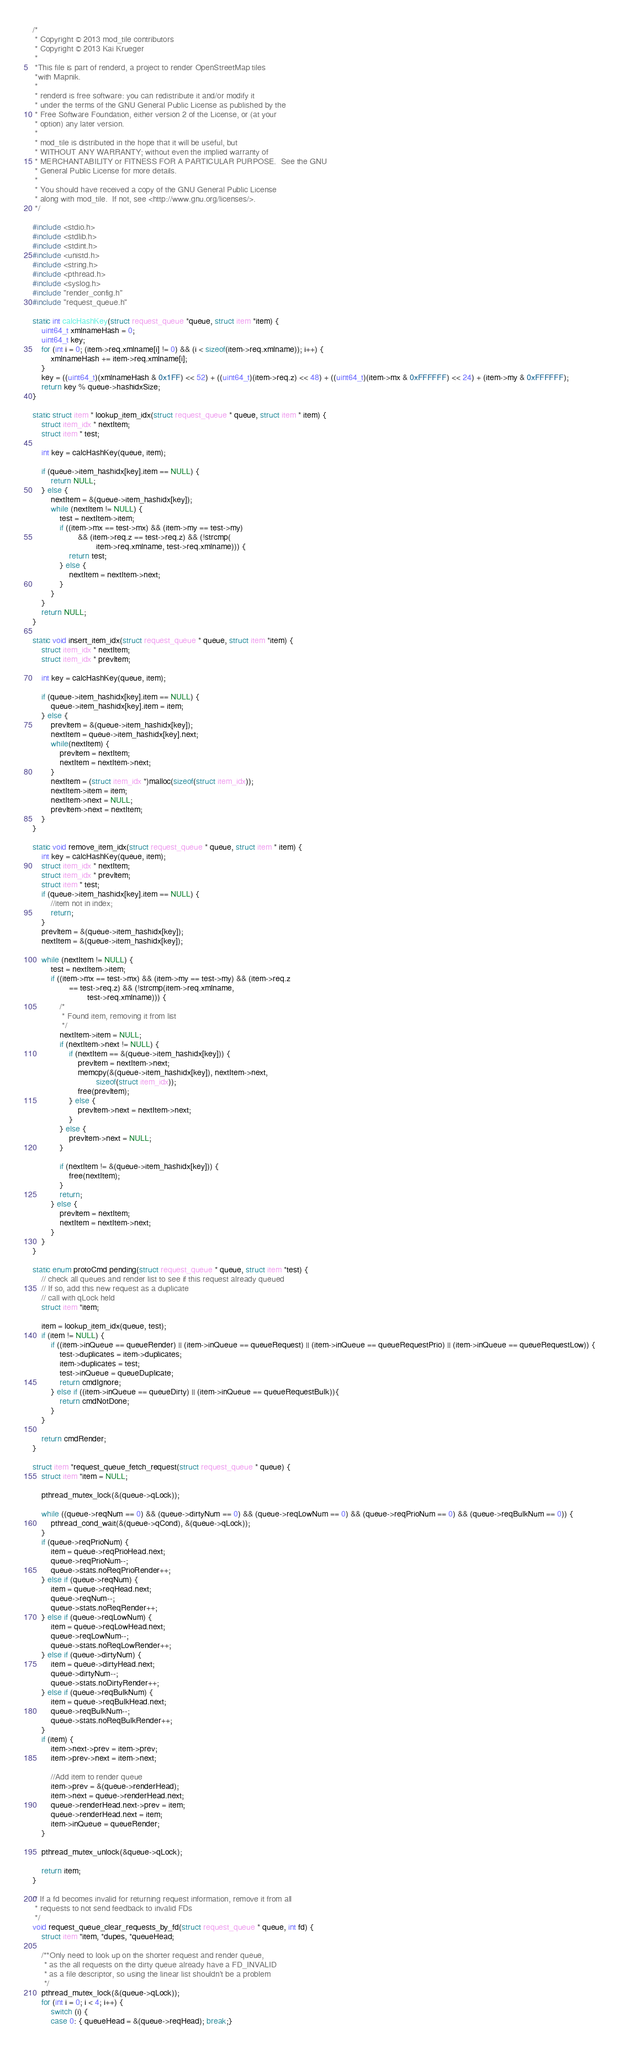Convert code to text. <code><loc_0><loc_0><loc_500><loc_500><_C_>/*
 * Copyright © 2013 mod_tile contributors
 * Copyright © 2013 Kai Krueger
 *
 *This file is part of renderd, a project to render OpenStreetMap tiles
 *with Mapnik.
 *
 * renderd is free software: you can redistribute it and/or modify it
 * under the terms of the GNU General Public License as published by the
 * Free Software Foundation, either version 2 of the License, or (at your
 * option) any later version.
 *
 * mod_tile is distributed in the hope that it will be useful, but
 * WITHOUT ANY WARRANTY; without even the implied warranty of
 * MERCHANTABILITY or FITNESS FOR A PARTICULAR PURPOSE.  See the GNU
 * General Public License for more details.
 *
 * You should have received a copy of the GNU General Public License
 * along with mod_tile.  If not, see <http://www.gnu.org/licenses/>.
 */

#include <stdio.h>
#include <stdlib.h>
#include <stdint.h>
#include <unistd.h>
#include <string.h>
#include <pthread.h>
#include <syslog.h>
#include "render_config.h"
#include "request_queue.h"

static int calcHashKey(struct request_queue *queue, struct item *item) {
    uint64_t xmlnameHash = 0;
    uint64_t key;
    for (int i = 0; (item->req.xmlname[i] != 0) && (i < sizeof(item->req.xmlname)); i++) {
        xmlnameHash += item->req.xmlname[i];
    }
    key = ((uint64_t)(xmlnameHash & 0x1FF) << 52) + ((uint64_t)(item->req.z) << 48) + ((uint64_t)(item->mx & 0xFFFFFF) << 24) + (item->my & 0xFFFFFF);
    return key % queue->hashidxSize;
}

static struct item * lookup_item_idx(struct request_queue * queue, struct item * item) {
    struct item_idx * nextItem;
    struct item * test;

    int key = calcHashKey(queue, item);

    if (queue->item_hashidx[key].item == NULL) {
        return NULL;
    } else {
        nextItem = &(queue->item_hashidx[key]);
        while (nextItem != NULL) {
            test = nextItem->item;
            if ((item->mx == test->mx) && (item->my == test->my)
                    && (item->req.z == test->req.z) && (!strcmp(
                            item->req.xmlname, test->req.xmlname))) {
                return test;
            } else {
                nextItem = nextItem->next;
            }
        }
    }
    return NULL;
}

static void insert_item_idx(struct request_queue * queue, struct item *item) {
    struct item_idx * nextItem;
    struct item_idx * prevItem;

    int key = calcHashKey(queue, item);

    if (queue->item_hashidx[key].item == NULL) {
        queue->item_hashidx[key].item = item;
    } else {
        prevItem = &(queue->item_hashidx[key]);
        nextItem = queue->item_hashidx[key].next;
        while(nextItem) {
            prevItem = nextItem;
            nextItem = nextItem->next;
        }
        nextItem = (struct item_idx *)malloc(sizeof(struct item_idx));
        nextItem->item = item;
        nextItem->next = NULL;
        prevItem->next = nextItem;
    }
}

static void remove_item_idx(struct request_queue * queue, struct item * item) {
    int key = calcHashKey(queue, item);
    struct item_idx * nextItem;
    struct item_idx * prevItem;
    struct item * test;
    if (queue->item_hashidx[key].item == NULL) {
        //item not in index;
        return;
    }
    prevItem = &(queue->item_hashidx[key]);
    nextItem = &(queue->item_hashidx[key]);

    while (nextItem != NULL) {
        test = nextItem->item;
        if ((item->mx == test->mx) && (item->my == test->my) && (item->req.z
                == test->req.z) && (!strcmp(item->req.xmlname,
                        test->req.xmlname))) {
            /*
             * Found item, removing it from list
             */
            nextItem->item = NULL;
            if (nextItem->next != NULL) {
                if (nextItem == &(queue->item_hashidx[key])) {
                    prevItem = nextItem->next;
                    memcpy(&(queue->item_hashidx[key]), nextItem->next,
                            sizeof(struct item_idx));
                    free(prevItem);
                } else {
                    prevItem->next = nextItem->next;
                }
            } else {
                prevItem->next = NULL;
            }

            if (nextItem != &(queue->item_hashidx[key])) {
                free(nextItem);
            }
            return;
        } else {
            prevItem = nextItem;
            nextItem = nextItem->next;
        }
    }
}

static enum protoCmd pending(struct request_queue * queue, struct item *test) {
    // check all queues and render list to see if this request already queued
    // If so, add this new request as a duplicate
    // call with qLock held
    struct item *item;

    item = lookup_item_idx(queue, test);
    if (item != NULL) {
        if ((item->inQueue == queueRender) || (item->inQueue == queueRequest) || (item->inQueue == queueRequestPrio) || (item->inQueue == queueRequestLow)) {
            test->duplicates = item->duplicates;
            item->duplicates = test;
            test->inQueue = queueDuplicate;
            return cmdIgnore;
        } else if ((item->inQueue == queueDirty) || (item->inQueue == queueRequestBulk)){
            return cmdNotDone;
        }
    }

    return cmdRender;
}

struct item *request_queue_fetch_request(struct request_queue * queue) {
    struct item *item = NULL;

    pthread_mutex_lock(&(queue->qLock));

    while ((queue->reqNum == 0) && (queue->dirtyNum == 0) && (queue->reqLowNum == 0) && (queue->reqPrioNum == 0) && (queue->reqBulkNum == 0)) {
        pthread_cond_wait(&(queue->qCond), &(queue->qLock));
    }
    if (queue->reqPrioNum) {
        item = queue->reqPrioHead.next;
        queue->reqPrioNum--;
        queue->stats.noReqPrioRender++;
    } else if (queue->reqNum) {
        item = queue->reqHead.next;
        queue->reqNum--;
        queue->stats.noReqRender++;
    } else if (queue->reqLowNum) {
        item = queue->reqLowHead.next;
        queue->reqLowNum--;
        queue->stats.noReqLowRender++;
    } else if (queue->dirtyNum) {
        item = queue->dirtyHead.next;
        queue->dirtyNum--;
        queue->stats.noDirtyRender++;
    } else if (queue->reqBulkNum) {
        item = queue->reqBulkHead.next;
        queue->reqBulkNum--;
        queue->stats.noReqBulkRender++;
    }
    if (item) {
        item->next->prev = item->prev;
        item->prev->next = item->next;

        //Add item to render queue
        item->prev = &(queue->renderHead);
        item->next = queue->renderHead.next;
        queue->renderHead.next->prev = item;
        queue->renderHead.next = item;
        item->inQueue = queueRender;
    }

    pthread_mutex_unlock(&queue->qLock);

    return item;
}

/* If a fd becomes invalid for returning request information, remove it from all
 * requests to not send feedback to invalid FDs
 */
void request_queue_clear_requests_by_fd(struct request_queue * queue, int fd) {
    struct item *item, *dupes, *queueHead;

    /**Only need to look up on the shorter request and render queue,
     * as the all requests on the dirty queue already have a FD_INVALID
     * as a file descriptor, so using the linear list shouldn't be a problem
     */
    pthread_mutex_lock(&(queue->qLock));
    for (int i = 0; i < 4; i++) {
        switch (i) {
        case 0: { queueHead = &(queue->reqHead); break;}</code> 